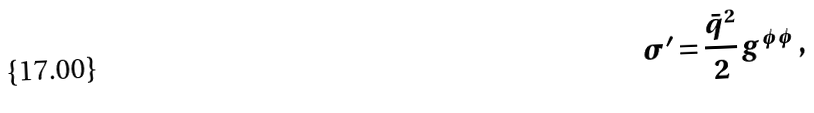<formula> <loc_0><loc_0><loc_500><loc_500>\sigma ^ { \prime } = \frac { \bar { q } ^ { 2 } } { 2 } g ^ { \phi \phi } \, ,</formula> 